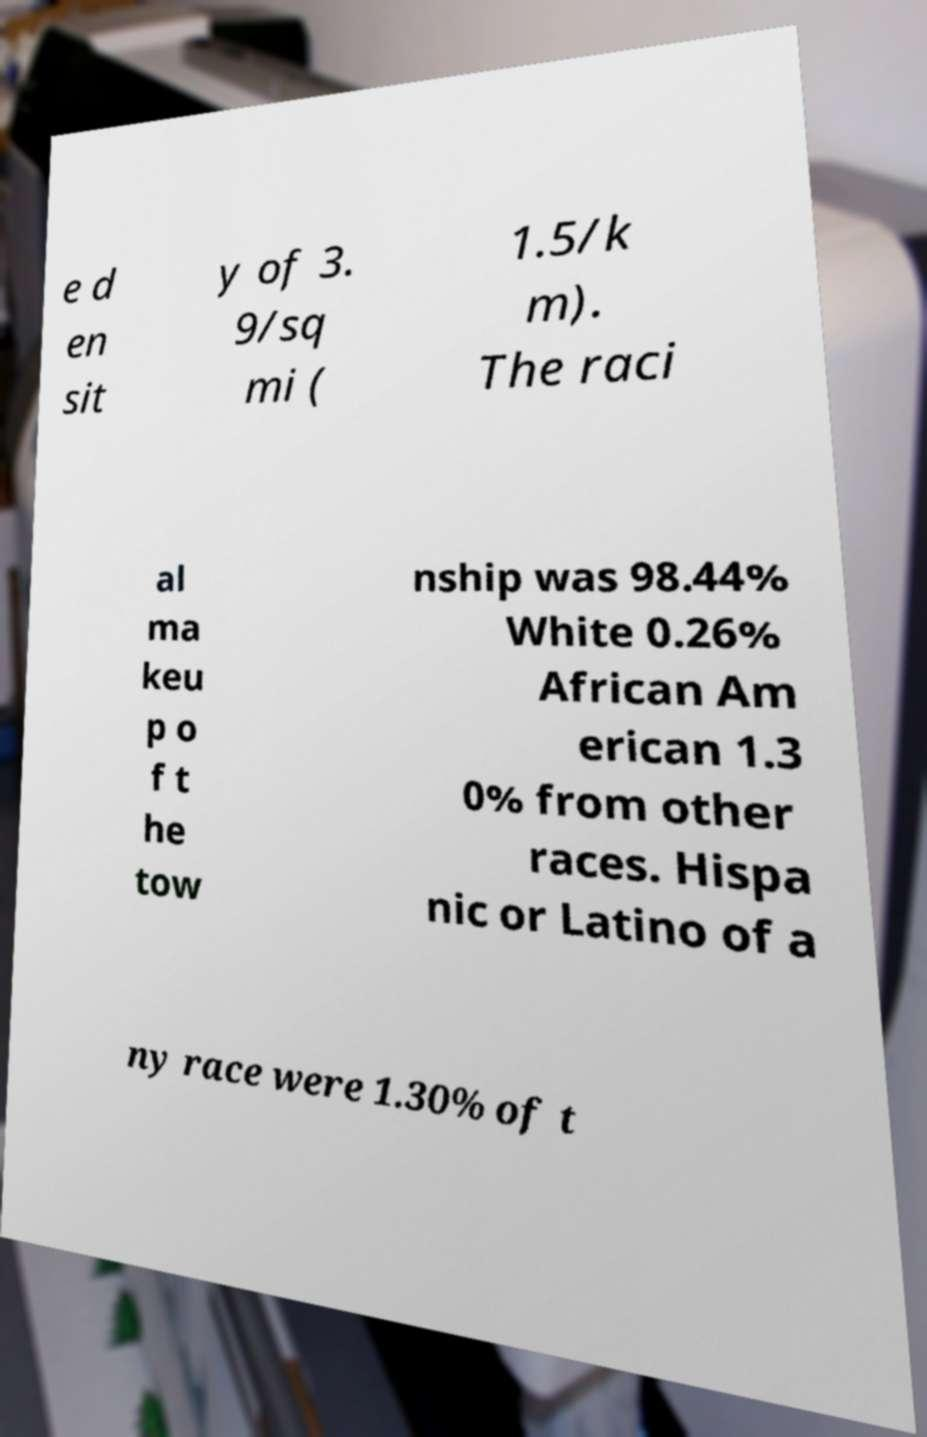Please identify and transcribe the text found in this image. e d en sit y of 3. 9/sq mi ( 1.5/k m). The raci al ma keu p o f t he tow nship was 98.44% White 0.26% African Am erican 1.3 0% from other races. Hispa nic or Latino of a ny race were 1.30% of t 